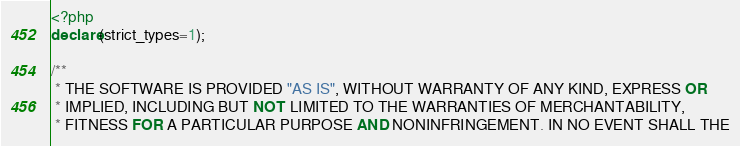Convert code to text. <code><loc_0><loc_0><loc_500><loc_500><_PHP_><?php
declare(strict_types=1);

/**
 * THE SOFTWARE IS PROVIDED "AS IS", WITHOUT WARRANTY OF ANY KIND, EXPRESS OR
 * IMPLIED, INCLUDING BUT NOT LIMITED TO THE WARRANTIES OF MERCHANTABILITY,
 * FITNESS FOR A PARTICULAR PURPOSE AND NONINFRINGEMENT. IN NO EVENT SHALL THE</code> 